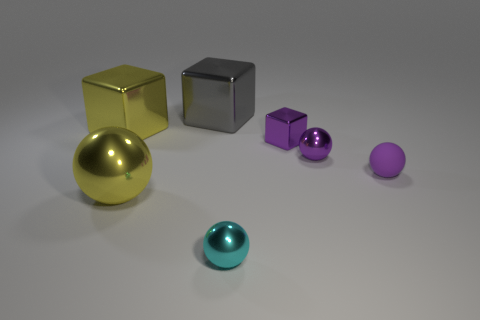Subtract all tiny cubes. How many cubes are left? 2 Subtract all brown cylinders. How many purple balls are left? 2 Subtract all yellow balls. How many balls are left? 3 Add 2 blocks. How many objects exist? 9 Subtract 2 cubes. How many cubes are left? 1 Subtract all blocks. How many objects are left? 4 Subtract all purple metal things. Subtract all tiny purple rubber balls. How many objects are left? 4 Add 5 big gray metallic cubes. How many big gray metallic cubes are left? 6 Add 7 tiny purple metal balls. How many tiny purple metal balls exist? 8 Subtract 0 green cylinders. How many objects are left? 7 